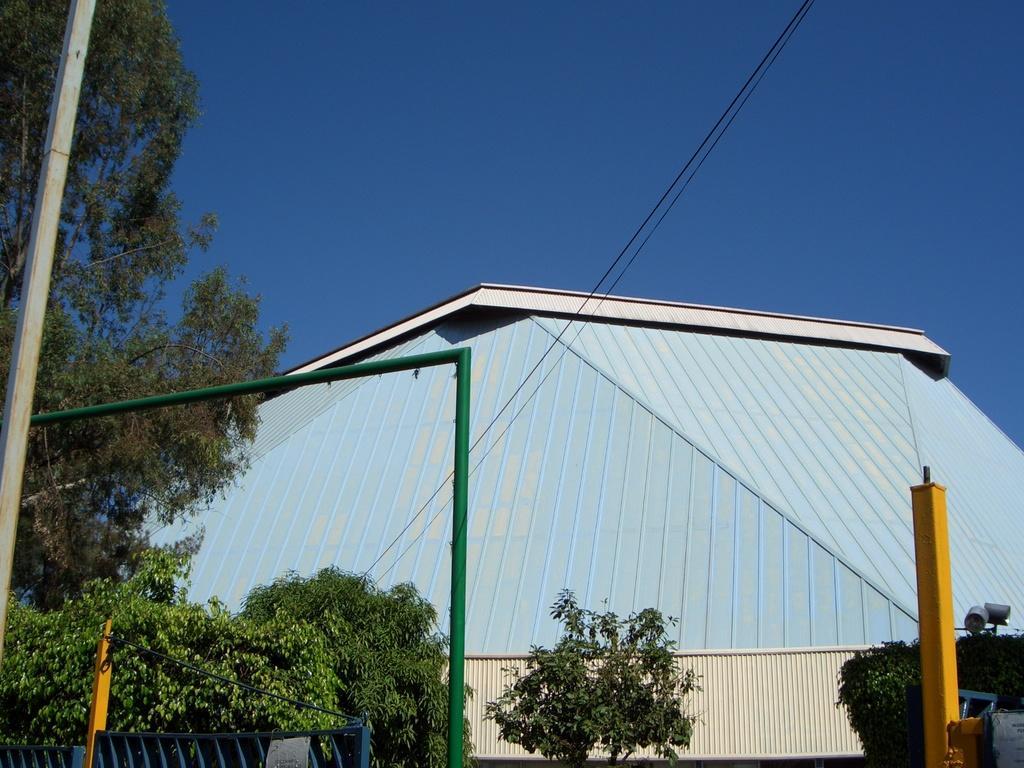Describe this image in one or two sentences. In this image in the center there are plants, poles and in the background there is a building and there are wires in front of the building. 